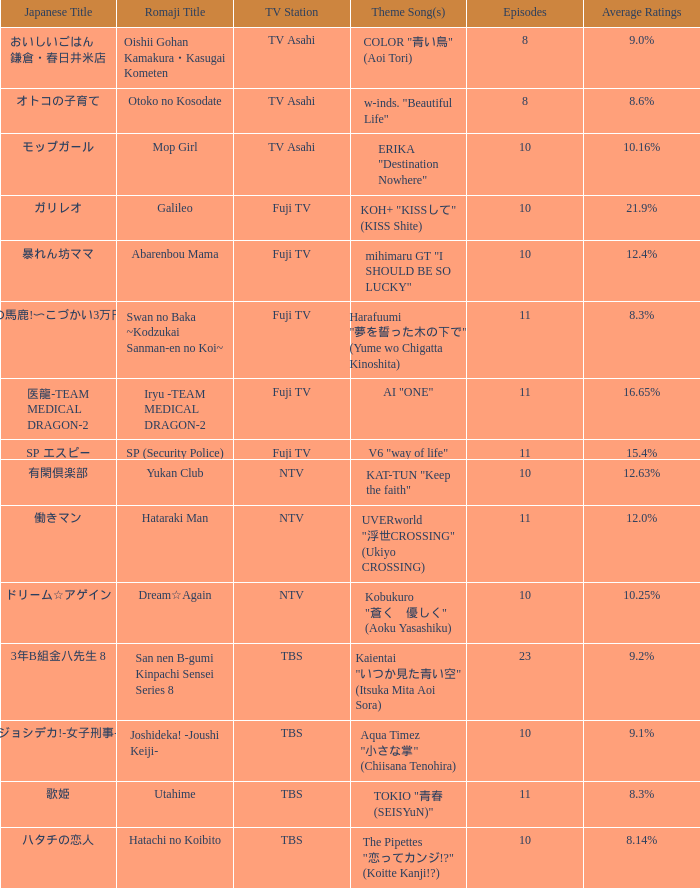What is the main tune of 働きマン? UVERworld "浮世CROSSING" (Ukiyo CROSSING). 